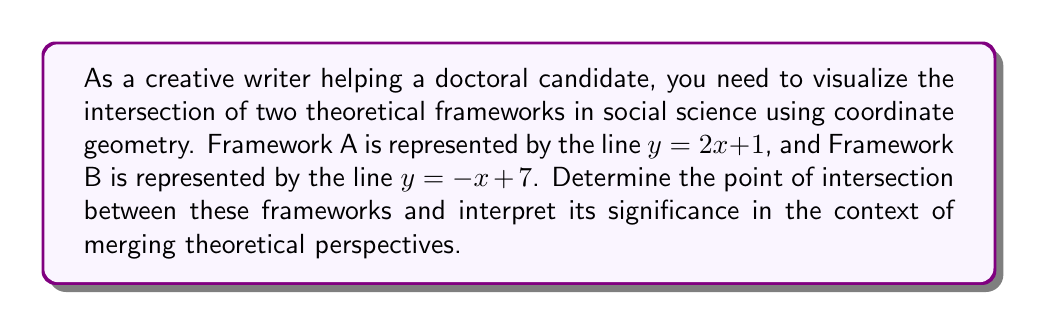Provide a solution to this math problem. To solve this problem, we'll follow these steps:

1. Find the point of intersection algebraically:
   To find the intersection point, we need to solve the system of equations:
   $$\begin{cases}
   y = 2x + 1 \\
   y = -x + 7
   \end{cases}$$

   Set the equations equal to each other:
   $$2x + 1 = -x + 7$$

   Solve for x:
   $$3x = 6$$
   $$x = 2$$

   Substitute x = 2 into either equation to find y:
   $$y = 2(2) + 1 = 5$$

   The point of intersection is (2, 5).

2. Visualize the intersection:
   [asy]
   import graph;
   size(200);
   xaxis("x", arrow=Arrow);
   yaxis("y", arrow=Arrow);
   draw((0,1)--(4,9), blue, L=Label("Framework A", position=EndPoint));
   draw((0,7)--(8,-1), red, L=Label("Framework B", position=EndPoint));
   dot((2,5), filltype=FillDraw(fillpen=black, drawpen=black));
   label("(2, 5)", (2,5), NE);
   [/asy]

3. Interpret the significance:
   The point of intersection (2, 5) represents the convergence of Frameworks A and B. In the context of merging theoretical perspectives, this point symbolizes:

   a) Common ground: The x-coordinate (2) could represent a shared concept or variable that both frameworks acknowledge.
   
   b) Synergy: The y-coordinate (5) might indicate a combined effect or outcome when both frameworks are considered together.
   
   c) Integration point: This intersection serves as a starting point for developing a more comprehensive theoretical model that incorporates elements from both frameworks.
   
   d) Comparative analysis: Researchers can use this point to examine how each framework approaches the same issue (x=2) and arrives at a common conclusion (y=5).

By visualizing theoretical frameworks as lines in a coordinate system, researchers can identify areas of overlap, divergence, and potential synthesis, leading to more nuanced and integrated theoretical approaches in their field.
Answer: The point of intersection between Framework A $(y = 2x + 1)$ and Framework B $(y = -x + 7)$ is $(2, 5)$. This point represents the convergence of the two theoretical perspectives, indicating a shared concept (x=2) and a combined outcome (y=5) that can serve as a foundation for integrating and comparing the frameworks in the research context. 